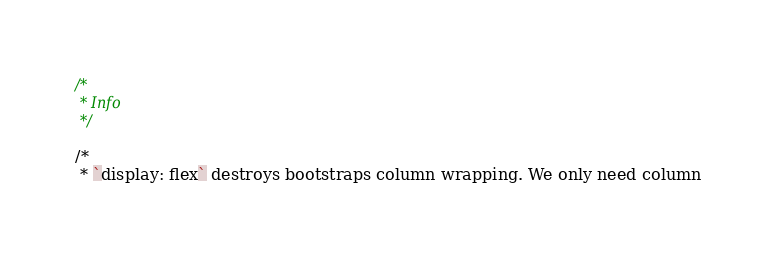Convert code to text. <code><loc_0><loc_0><loc_500><loc_500><_CSS_>/*
 * Info
 */

/*
 * `display: flex` destroys bootstraps column wrapping. We only need column</code> 